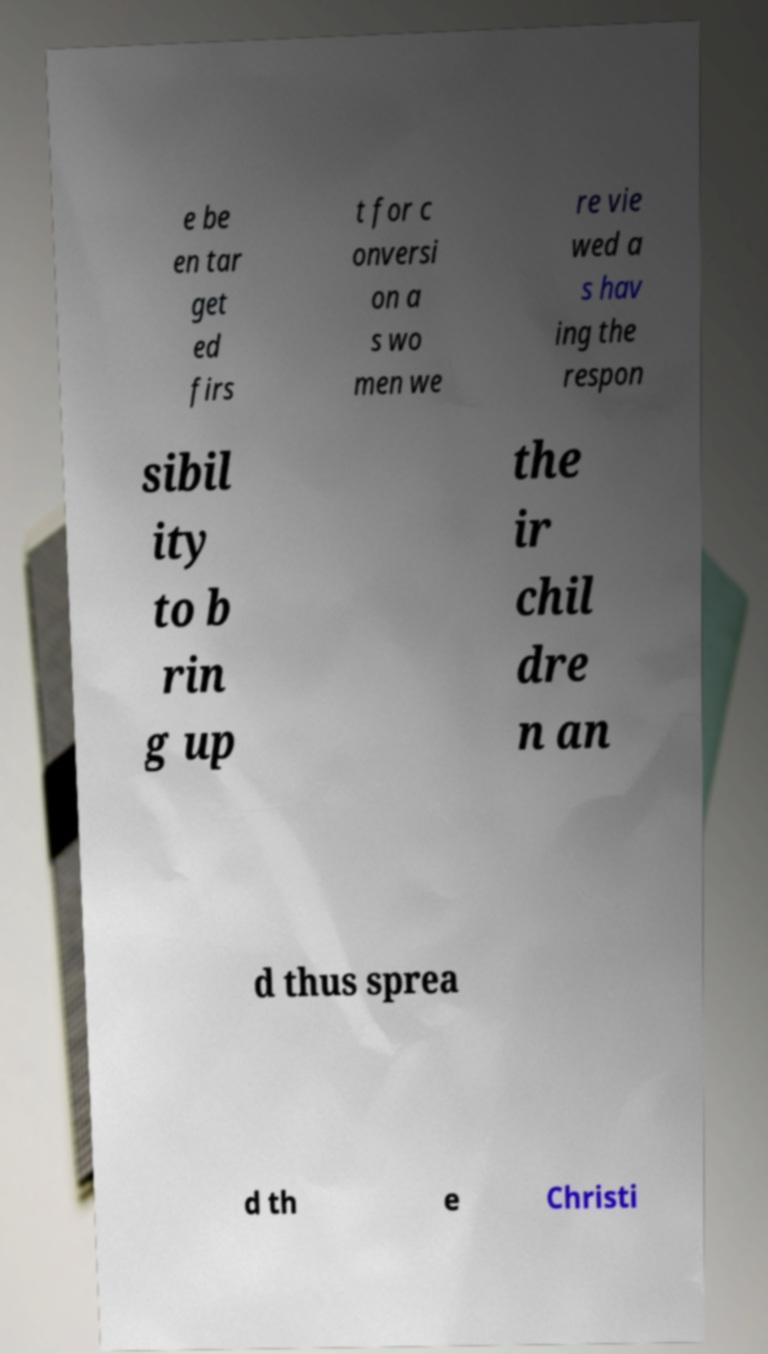Please identify and transcribe the text found in this image. e be en tar get ed firs t for c onversi on a s wo men we re vie wed a s hav ing the respon sibil ity to b rin g up the ir chil dre n an d thus sprea d th e Christi 